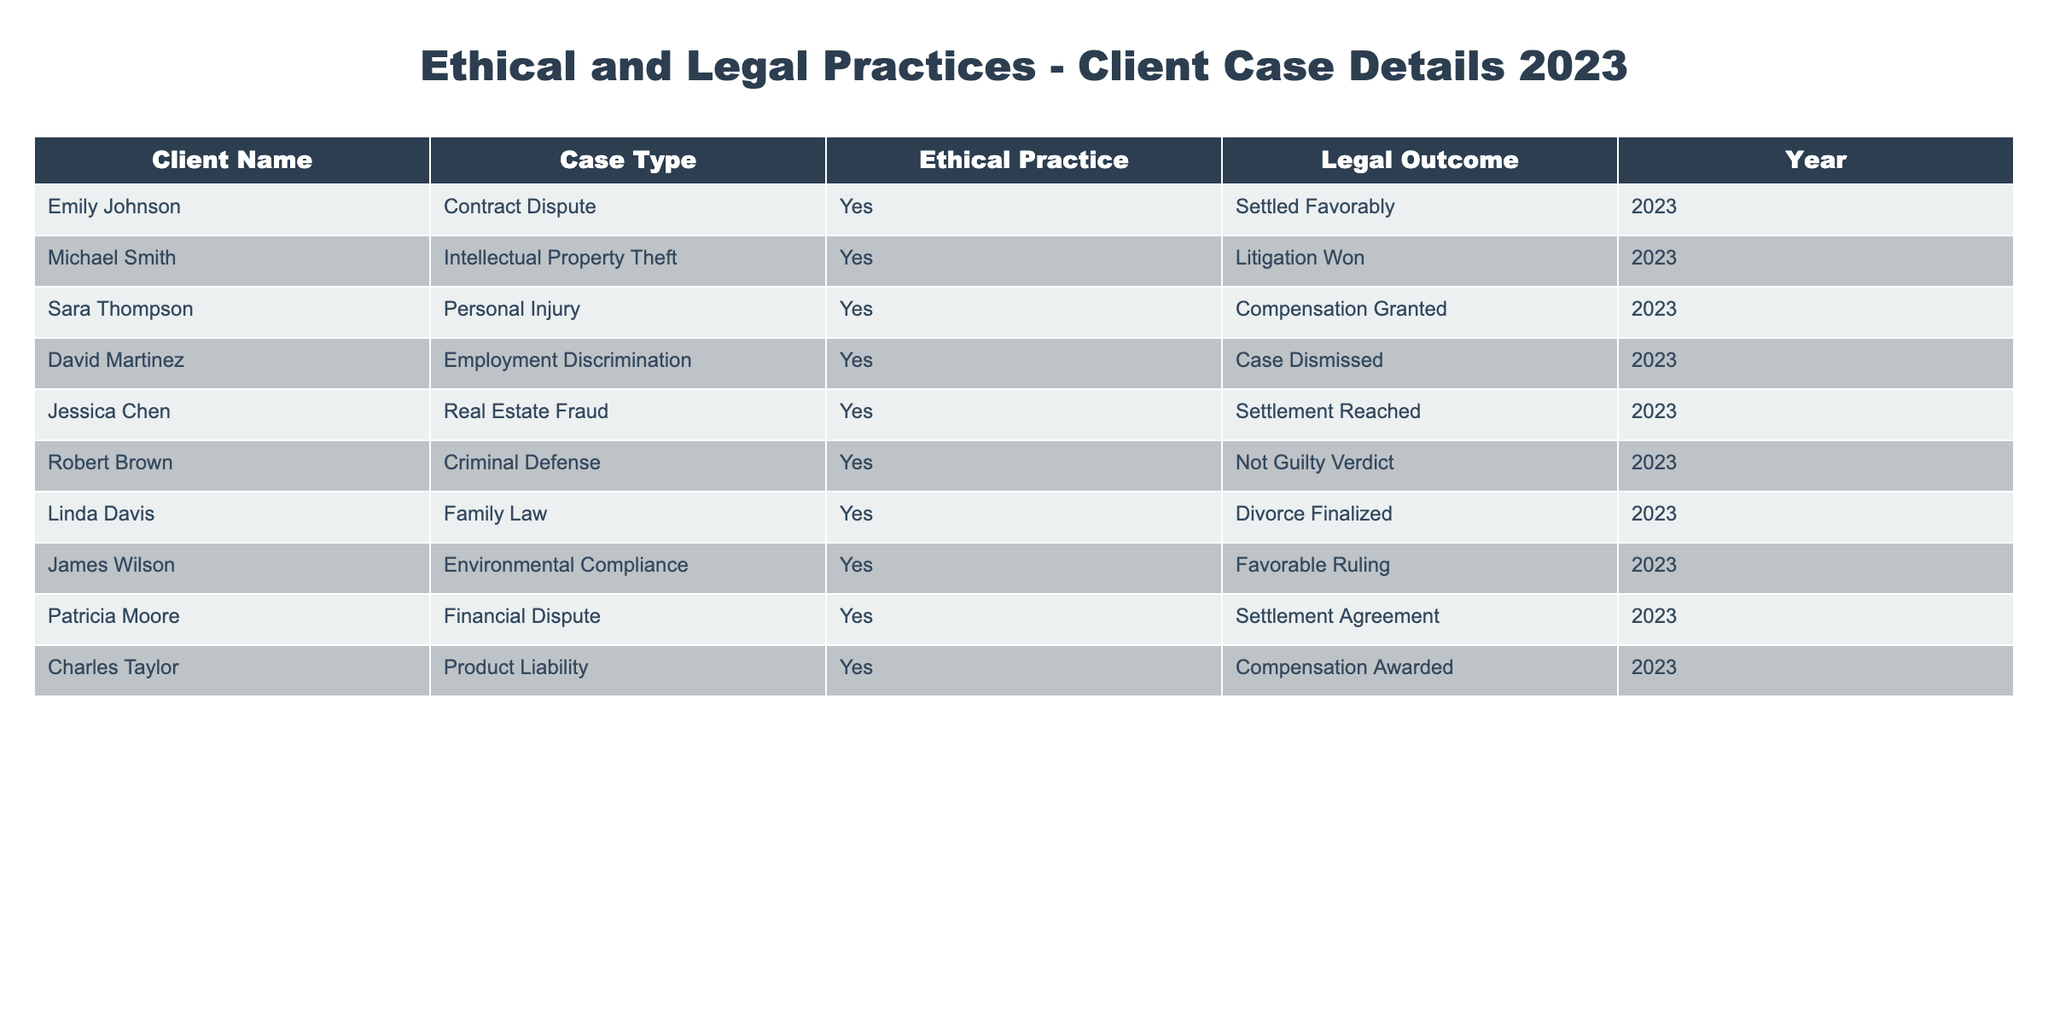What is the legal outcome for Emily Johnson's case? From the table, we can directly find the entry for Emily Johnson. She is involved in a Contract Dispute and the legal outcome stated for her case is "Settled Favorably."
Answer: Settled Favorably How many clients had a favorable legal outcome in 2023? A favorable legal outcome is defined as either "Settled Favorably," "Litigation Won," "Compensation Granted," "Settlement Reached," "Not Guilty Verdict," "Divorce Finalized," "Favorable Ruling," or "Compensation Awarded." By counting each case in the table that fits this criterion, we find 10 clients had favorable outcomes.
Answer: 10 Is there a case type listed for Linda Davis? According to the table, Linda Davis is associated with Family Law. We can refer to her entry to confirm this information.
Answer: Yes Which client achieved compensation in their case? We can look at the outcomes of all clients and check for the ones that state compensation. From the data, Sara Thompson and Charles Taylor both received compensation: Sara stated "Compensation Granted" and Charles stated "Compensation Awarded."
Answer: Sara Thompson, Charles Taylor What is the most common case type among the clients listed? To find the most common case type, we can analyze the distinct cases provided in the table. There are various case types, but since all clients had different issues, we see that each case type only appears once. Therefore, there is no repeat case type to declare as the most common.
Answer: No common case type How many cases resulted in a dismissal or a not guilty verdict? We look at the table for case outcomes that indicate dismissal or not guilty. David Martinez's case was "Case Dismissed," and Robert Brown's case resulted in a "Not Guilty Verdict." Together these count as two cases resulting in dismissal or a not guilty verdict.
Answer: 2 Did any clients face a case outcome that was not favorable? In the table, all clients have favorable outcomes according to the defined terms. Therefore, there are no clients that faced an unfavorable outcome.
Answer: No Which case types resulted in settlements? To determine the cases that reached settlements, we can filter through the table and find that the case types are Contract Dispute, Real Estate Fraud, and Financial Dispute, all of which led to settlements ("Settled Favorably," "Settlement Reached," and "Settlement Agreement").
Answer: Contract Dispute, Real Estate Fraud, Financial Dispute 